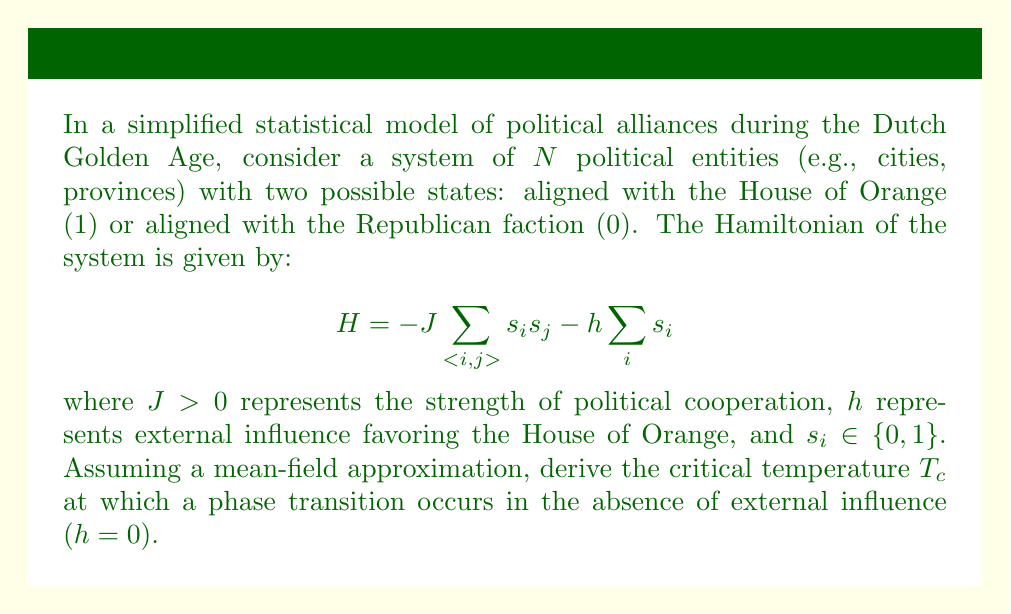Help me with this question. To solve this problem, we'll follow these steps:

1) In the mean-field approximation, we assume each entity interacts with the average state of the system. Let $m$ be the average state (magnetization in the Ising model analogy):

   $$m = \frac{1}{N}\sum_i \langle s_i \rangle$$

2) The effective field experienced by each entity is:

   $$h_{eff} = zJm + h$$

   where $z$ is the number of nearest neighbors (coordination number).

3) In the absence of external influence ($h = 0$), the effective field is:

   $$h_{eff} = zJm$$

4) The probability of an entity being in state 1 is given by the Fermi-Dirac distribution:

   $$p(1) = \frac{1}{1 + e^{-\beta h_{eff}}}$$

   where $\beta = \frac{1}{k_B T}$, $k_B$ is Boltzmann's constant, and $T$ is temperature.

5) The average state $m$ is equal to this probability:

   $$m = \frac{1}{1 + e^{-\beta zJm}}$$

6) At the critical temperature, this equation has a non-zero solution. We can find this by expanding the equation for small $m$:

   $$m \approx \frac{1}{2} + \frac{\beta zJm}{4} - \frac{(\beta zJm)^3}{48} + ...$$

7) For a non-zero solution to exist, we must have:

   $$\frac{\beta zJ}{4} = 1$$

8) Solving for the critical temperature:

   $$T_c = \frac{zJ}{4k_B}$$

This is the temperature above which the system will be in a disordered state (no clear majority alignment), and below which it will tend to align predominantly with one faction.
Answer: $T_c = \frac{zJ}{4k_B}$ 